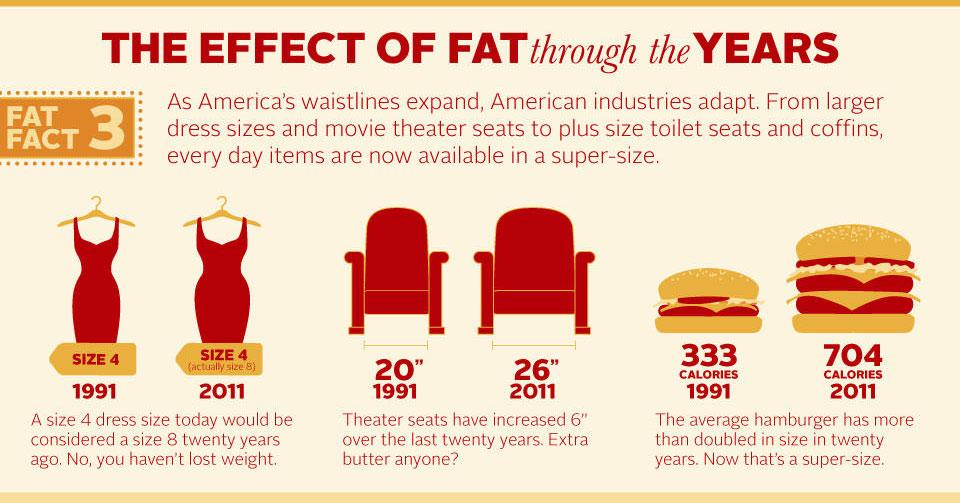Give some essential details in this illustration. The size of theater seats in 2011 was 26 inches. In 2011, the average calorie content of a hamburger was 704 calories. 